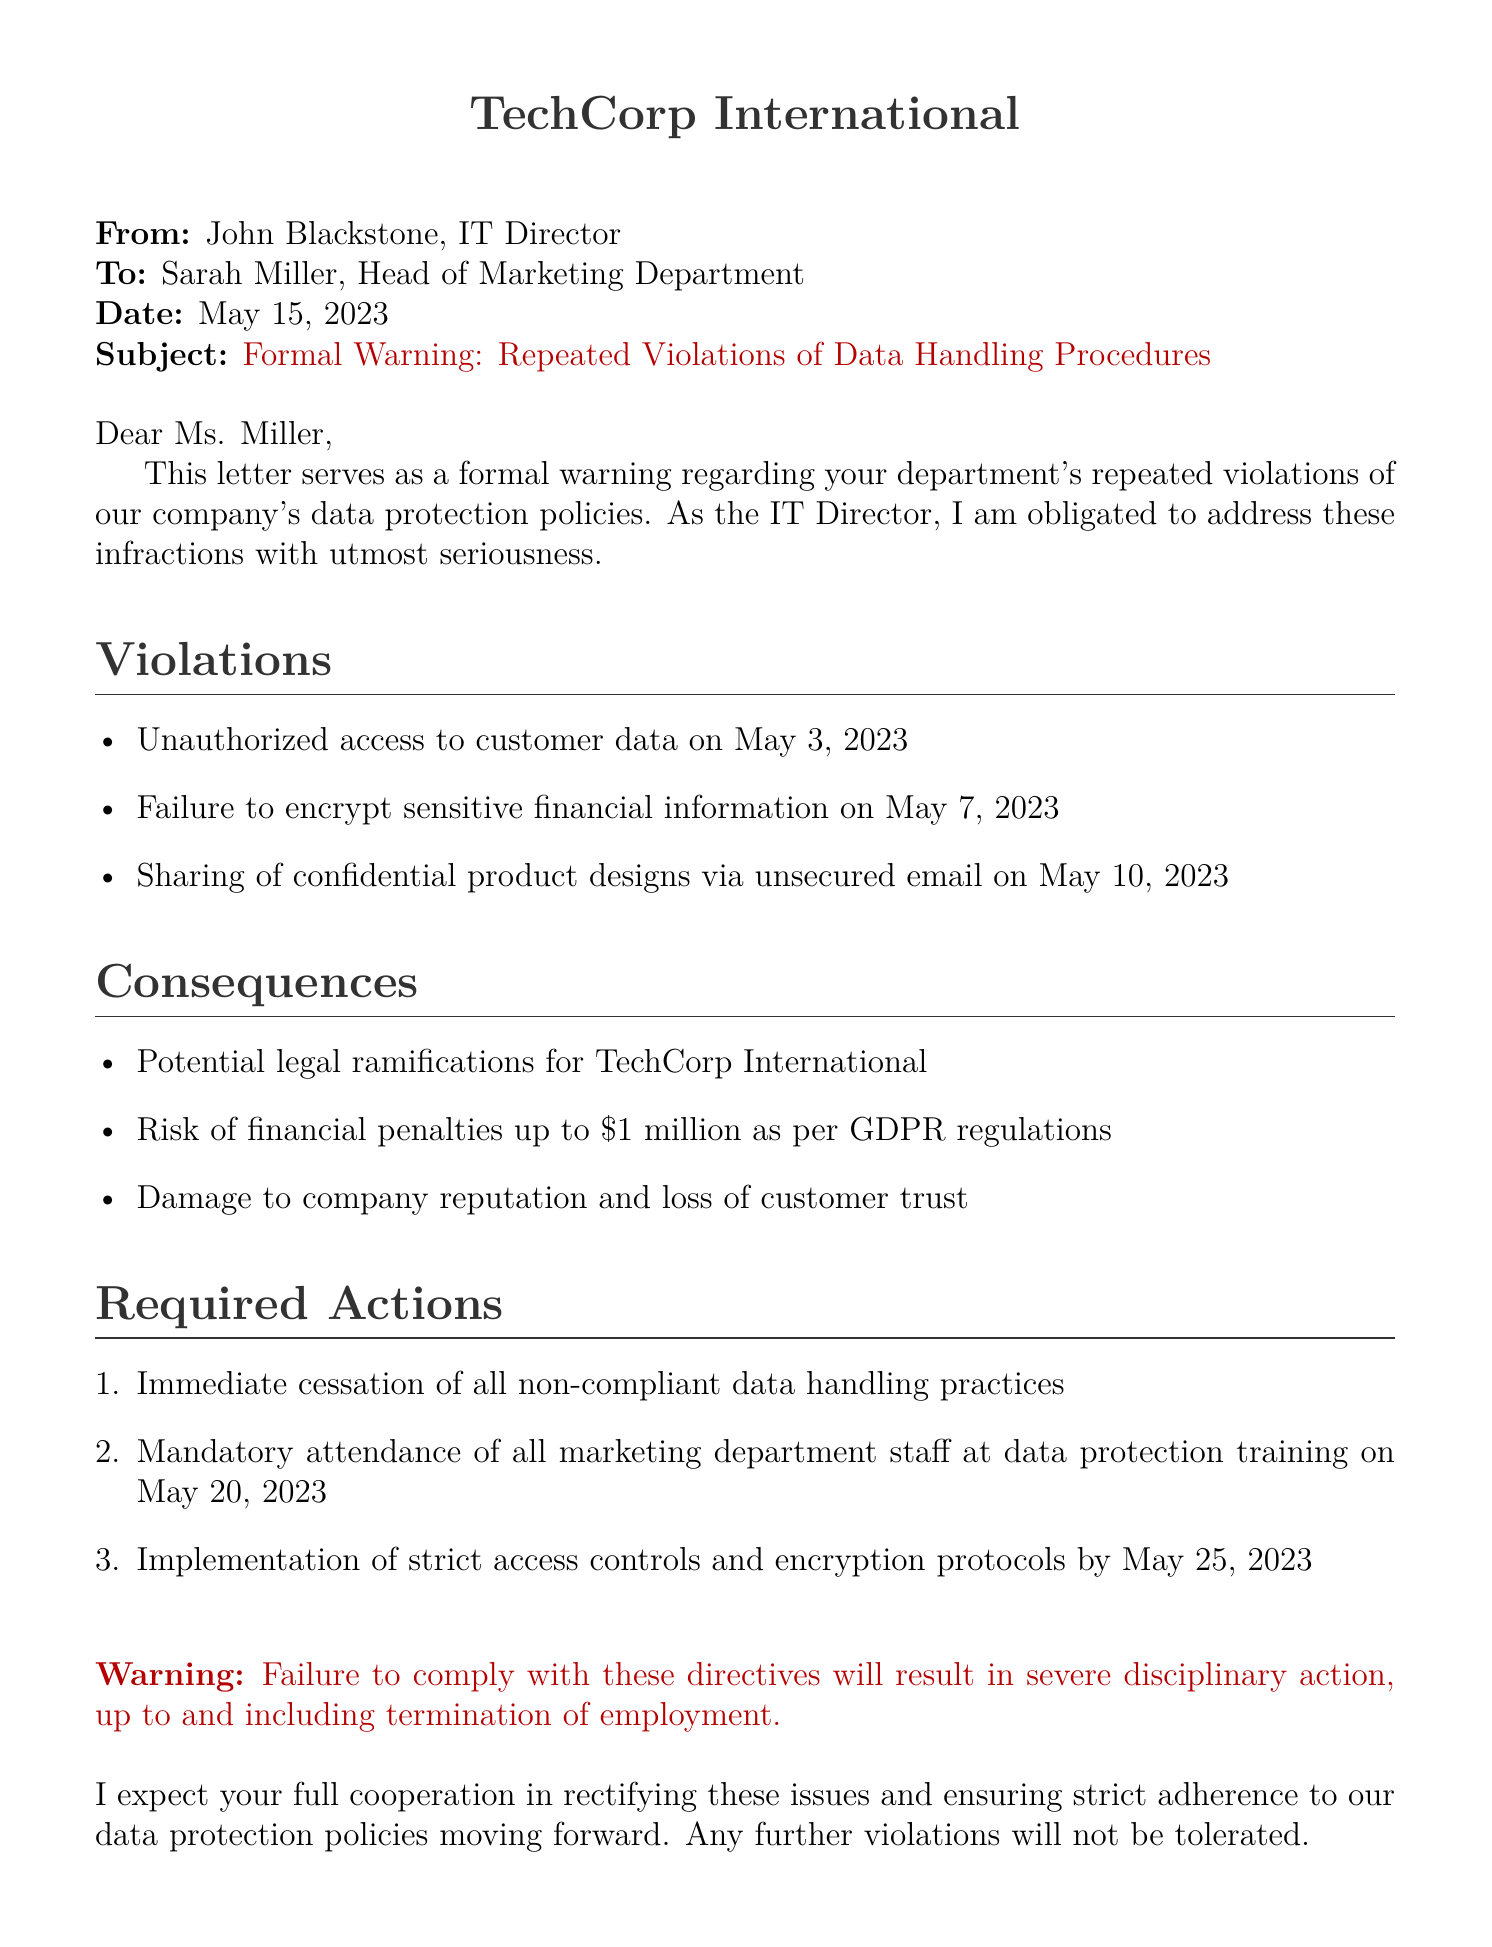What is the date of the warning letter? The date is specified in the header of the document.
Answer: May 15, 2023 Who is the sender of the letter? The sender's name is mentioned in the "From" section of the document.
Answer: John Blackstone What incident occurred on May 3, 2023? The document lists specific violations with associated dates.
Answer: Unauthorized access to customer data How much could the financial penalties be as per GDPR regulations? The amount is stated in the "Consequences" section of the document.
Answer: \$1 million What is the deadline for implementing strict access controls and encryption protocols? The document specifies required actions with deadlines.
Answer: May 25, 2023 What training event is mandatory for the marketing department staff? A specific requirement is mentioned in the "Required Actions" section of the document.
Answer: Data protection training What color is the subject line of the letter? The document describes the text color used for the subject line.
Answer: Warning What action is recommended regarding non-compliant data handling practices? The document describes required actions to be taken.
Answer: Immediate cessation What is the potential consequence of failure to comply with the directives? The document outlines severe consequences for non-compliance.
Answer: Termination of employment 